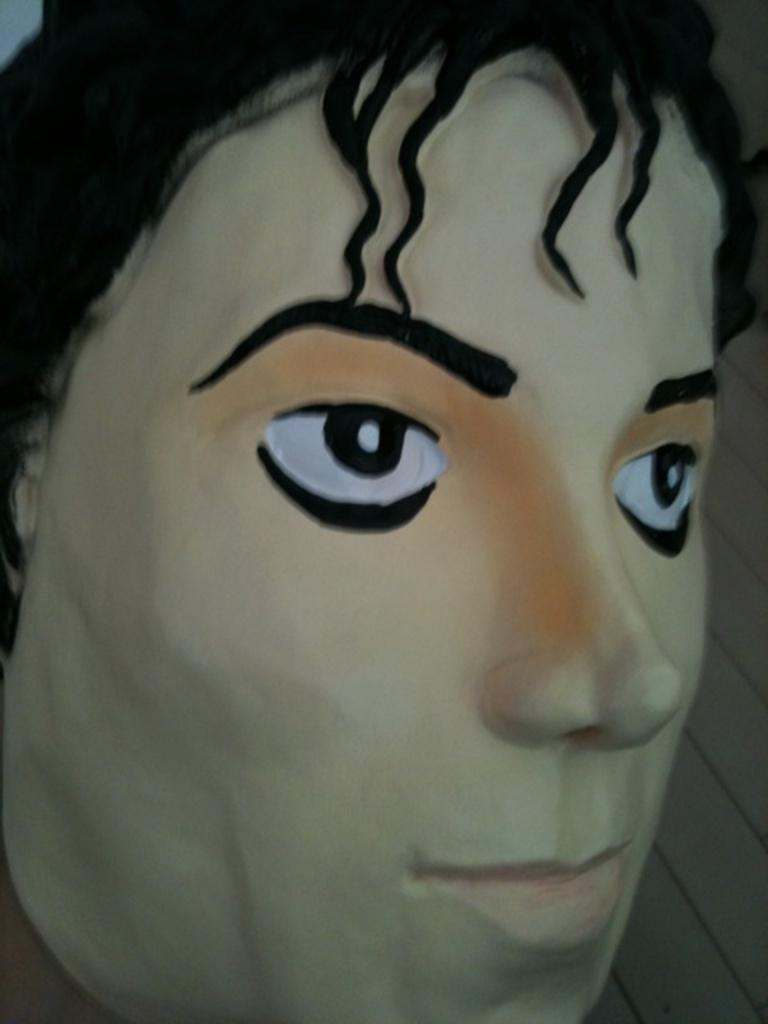How would you summarize this image in a sentence or two? This is a depiction of a human face. 